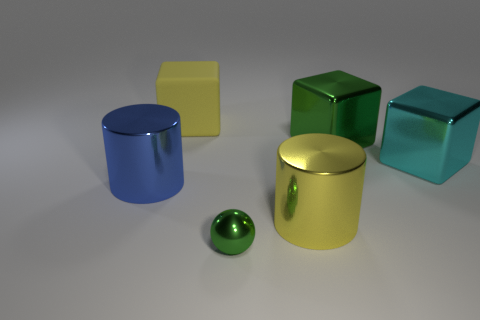Add 1 big cyan metallic things. How many objects exist? 7 Subtract all balls. How many objects are left? 5 Subtract 0 yellow balls. How many objects are left? 6 Subtract all shiny cylinders. Subtract all small cyan cylinders. How many objects are left? 4 Add 5 large blocks. How many large blocks are left? 8 Add 1 tiny red matte cylinders. How many tiny red matte cylinders exist? 1 